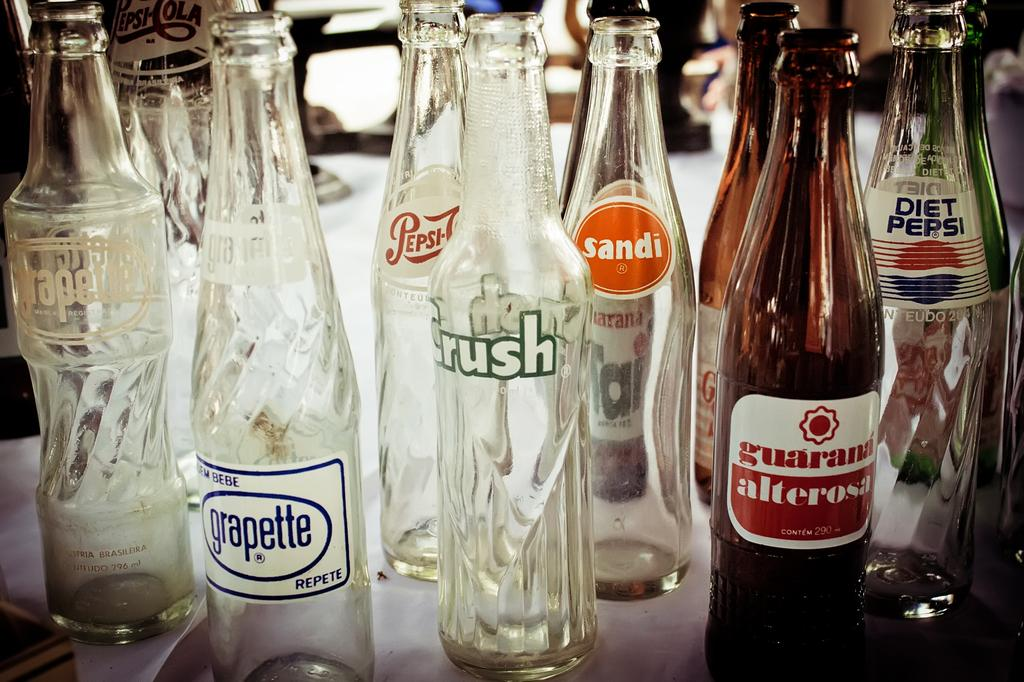What objects are present on the table in the image? There are many bottles on the table. What can be found on the surface of the bottles? The bottles have labels on them. What type of lumber is being used to construct the table in the image? There is no information about the table's construction or the type of lumber used in the image. 